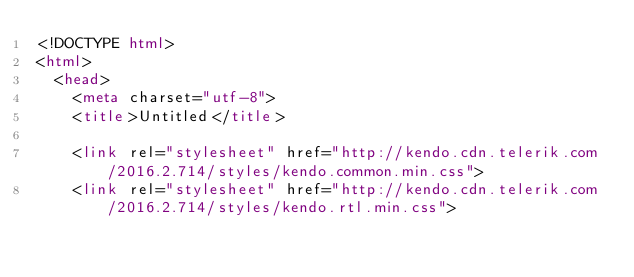<code> <loc_0><loc_0><loc_500><loc_500><_HTML_><!DOCTYPE html>
<html>
  <head>
    <meta charset="utf-8">
    <title>Untitled</title>

    <link rel="stylesheet" href="http://kendo.cdn.telerik.com/2016.2.714/styles/kendo.common.min.css">
    <link rel="stylesheet" href="http://kendo.cdn.telerik.com/2016.2.714/styles/kendo.rtl.min.css"></code> 